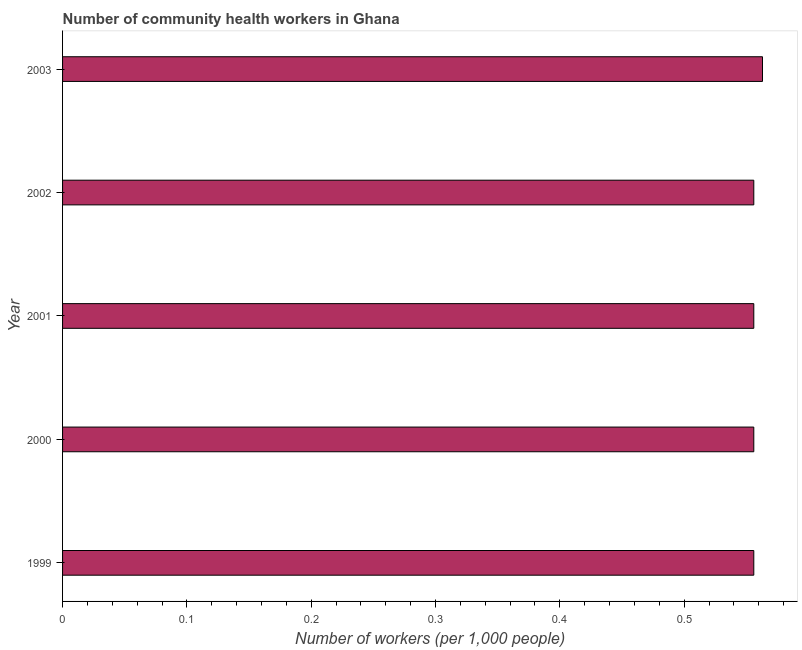Does the graph contain grids?
Ensure brevity in your answer.  No. What is the title of the graph?
Keep it short and to the point. Number of community health workers in Ghana. What is the label or title of the X-axis?
Offer a terse response. Number of workers (per 1,0 people). What is the number of community health workers in 2003?
Ensure brevity in your answer.  0.56. Across all years, what is the maximum number of community health workers?
Your response must be concise. 0.56. Across all years, what is the minimum number of community health workers?
Your answer should be compact. 0.56. What is the sum of the number of community health workers?
Your answer should be compact. 2.79. What is the difference between the number of community health workers in 2000 and 2002?
Your answer should be compact. 0. What is the average number of community health workers per year?
Keep it short and to the point. 0.56. What is the median number of community health workers?
Provide a short and direct response. 0.56. Do a majority of the years between 2003 and 2000 (inclusive) have number of community health workers greater than 0.38 ?
Offer a very short reply. Yes. What is the difference between the highest and the second highest number of community health workers?
Ensure brevity in your answer.  0.01. Is the sum of the number of community health workers in 2000 and 2001 greater than the maximum number of community health workers across all years?
Make the answer very short. Yes. What is the difference between the highest and the lowest number of community health workers?
Keep it short and to the point. 0.01. How many bars are there?
Your answer should be very brief. 5. Are all the bars in the graph horizontal?
Provide a succinct answer. Yes. How many years are there in the graph?
Provide a short and direct response. 5. What is the Number of workers (per 1,000 people) in 1999?
Your response must be concise. 0.56. What is the Number of workers (per 1,000 people) in 2000?
Make the answer very short. 0.56. What is the Number of workers (per 1,000 people) of 2001?
Your response must be concise. 0.56. What is the Number of workers (per 1,000 people) in 2002?
Your answer should be compact. 0.56. What is the Number of workers (per 1,000 people) in 2003?
Your answer should be very brief. 0.56. What is the difference between the Number of workers (per 1,000 people) in 1999 and 2002?
Your answer should be compact. 0. What is the difference between the Number of workers (per 1,000 people) in 1999 and 2003?
Offer a terse response. -0.01. What is the difference between the Number of workers (per 1,000 people) in 2000 and 2001?
Give a very brief answer. 0. What is the difference between the Number of workers (per 1,000 people) in 2000 and 2002?
Offer a terse response. 0. What is the difference between the Number of workers (per 1,000 people) in 2000 and 2003?
Provide a short and direct response. -0.01. What is the difference between the Number of workers (per 1,000 people) in 2001 and 2003?
Your response must be concise. -0.01. What is the difference between the Number of workers (per 1,000 people) in 2002 and 2003?
Offer a terse response. -0.01. What is the ratio of the Number of workers (per 1,000 people) in 1999 to that in 2001?
Provide a succinct answer. 1. What is the ratio of the Number of workers (per 1,000 people) in 1999 to that in 2002?
Your answer should be compact. 1. What is the ratio of the Number of workers (per 1,000 people) in 2000 to that in 2003?
Give a very brief answer. 0.99. What is the ratio of the Number of workers (per 1,000 people) in 2001 to that in 2002?
Your answer should be very brief. 1. What is the ratio of the Number of workers (per 1,000 people) in 2002 to that in 2003?
Keep it short and to the point. 0.99. 